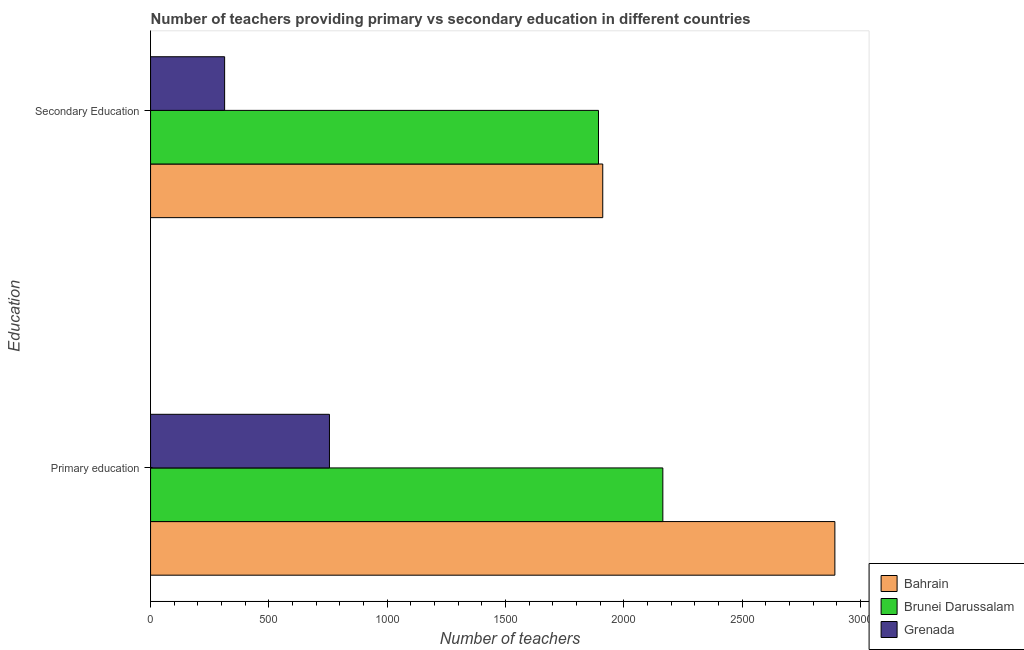Are the number of bars per tick equal to the number of legend labels?
Offer a very short reply. Yes. Are the number of bars on each tick of the Y-axis equal?
Your response must be concise. Yes. How many bars are there on the 2nd tick from the bottom?
Give a very brief answer. 3. What is the label of the 1st group of bars from the top?
Keep it short and to the point. Secondary Education. What is the number of primary teachers in Brunei Darussalam?
Provide a short and direct response. 2165. Across all countries, what is the maximum number of secondary teachers?
Your answer should be compact. 1911. Across all countries, what is the minimum number of secondary teachers?
Provide a succinct answer. 313. In which country was the number of secondary teachers maximum?
Make the answer very short. Bahrain. In which country was the number of primary teachers minimum?
Offer a very short reply. Grenada. What is the total number of primary teachers in the graph?
Offer a terse response. 5813. What is the difference between the number of secondary teachers in Brunei Darussalam and that in Bahrain?
Offer a terse response. -18. What is the difference between the number of primary teachers in Bahrain and the number of secondary teachers in Grenada?
Keep it short and to the point. 2579. What is the average number of primary teachers per country?
Your answer should be compact. 1937.67. What is the difference between the number of secondary teachers and number of primary teachers in Grenada?
Your answer should be compact. -443. What is the ratio of the number of secondary teachers in Grenada to that in Bahrain?
Make the answer very short. 0.16. What does the 2nd bar from the top in Secondary Education represents?
Make the answer very short. Brunei Darussalam. What does the 1st bar from the bottom in Primary education represents?
Offer a terse response. Bahrain. How many countries are there in the graph?
Your answer should be very brief. 3. What is the difference between two consecutive major ticks on the X-axis?
Provide a short and direct response. 500. Does the graph contain any zero values?
Ensure brevity in your answer.  No. Does the graph contain grids?
Ensure brevity in your answer.  No. How are the legend labels stacked?
Your response must be concise. Vertical. What is the title of the graph?
Provide a short and direct response. Number of teachers providing primary vs secondary education in different countries. What is the label or title of the X-axis?
Provide a short and direct response. Number of teachers. What is the label or title of the Y-axis?
Your answer should be compact. Education. What is the Number of teachers in Bahrain in Primary education?
Your answer should be compact. 2892. What is the Number of teachers of Brunei Darussalam in Primary education?
Your answer should be very brief. 2165. What is the Number of teachers of Grenada in Primary education?
Your response must be concise. 756. What is the Number of teachers in Bahrain in Secondary Education?
Provide a succinct answer. 1911. What is the Number of teachers in Brunei Darussalam in Secondary Education?
Give a very brief answer. 1893. What is the Number of teachers of Grenada in Secondary Education?
Give a very brief answer. 313. Across all Education, what is the maximum Number of teachers in Bahrain?
Make the answer very short. 2892. Across all Education, what is the maximum Number of teachers in Brunei Darussalam?
Offer a very short reply. 2165. Across all Education, what is the maximum Number of teachers in Grenada?
Offer a terse response. 756. Across all Education, what is the minimum Number of teachers in Bahrain?
Offer a terse response. 1911. Across all Education, what is the minimum Number of teachers of Brunei Darussalam?
Ensure brevity in your answer.  1893. Across all Education, what is the minimum Number of teachers in Grenada?
Offer a very short reply. 313. What is the total Number of teachers in Bahrain in the graph?
Offer a terse response. 4803. What is the total Number of teachers of Brunei Darussalam in the graph?
Make the answer very short. 4058. What is the total Number of teachers of Grenada in the graph?
Make the answer very short. 1069. What is the difference between the Number of teachers of Bahrain in Primary education and that in Secondary Education?
Offer a very short reply. 981. What is the difference between the Number of teachers of Brunei Darussalam in Primary education and that in Secondary Education?
Ensure brevity in your answer.  272. What is the difference between the Number of teachers of Grenada in Primary education and that in Secondary Education?
Provide a short and direct response. 443. What is the difference between the Number of teachers of Bahrain in Primary education and the Number of teachers of Brunei Darussalam in Secondary Education?
Offer a terse response. 999. What is the difference between the Number of teachers in Bahrain in Primary education and the Number of teachers in Grenada in Secondary Education?
Provide a short and direct response. 2579. What is the difference between the Number of teachers in Brunei Darussalam in Primary education and the Number of teachers in Grenada in Secondary Education?
Ensure brevity in your answer.  1852. What is the average Number of teachers in Bahrain per Education?
Make the answer very short. 2401.5. What is the average Number of teachers of Brunei Darussalam per Education?
Provide a succinct answer. 2029. What is the average Number of teachers of Grenada per Education?
Your answer should be very brief. 534.5. What is the difference between the Number of teachers of Bahrain and Number of teachers of Brunei Darussalam in Primary education?
Make the answer very short. 727. What is the difference between the Number of teachers in Bahrain and Number of teachers in Grenada in Primary education?
Keep it short and to the point. 2136. What is the difference between the Number of teachers in Brunei Darussalam and Number of teachers in Grenada in Primary education?
Ensure brevity in your answer.  1409. What is the difference between the Number of teachers in Bahrain and Number of teachers in Grenada in Secondary Education?
Your answer should be compact. 1598. What is the difference between the Number of teachers in Brunei Darussalam and Number of teachers in Grenada in Secondary Education?
Ensure brevity in your answer.  1580. What is the ratio of the Number of teachers of Bahrain in Primary education to that in Secondary Education?
Keep it short and to the point. 1.51. What is the ratio of the Number of teachers of Brunei Darussalam in Primary education to that in Secondary Education?
Offer a terse response. 1.14. What is the ratio of the Number of teachers in Grenada in Primary education to that in Secondary Education?
Provide a short and direct response. 2.42. What is the difference between the highest and the second highest Number of teachers of Bahrain?
Offer a very short reply. 981. What is the difference between the highest and the second highest Number of teachers of Brunei Darussalam?
Your answer should be very brief. 272. What is the difference between the highest and the second highest Number of teachers of Grenada?
Keep it short and to the point. 443. What is the difference between the highest and the lowest Number of teachers of Bahrain?
Provide a succinct answer. 981. What is the difference between the highest and the lowest Number of teachers of Brunei Darussalam?
Offer a terse response. 272. What is the difference between the highest and the lowest Number of teachers in Grenada?
Your answer should be very brief. 443. 